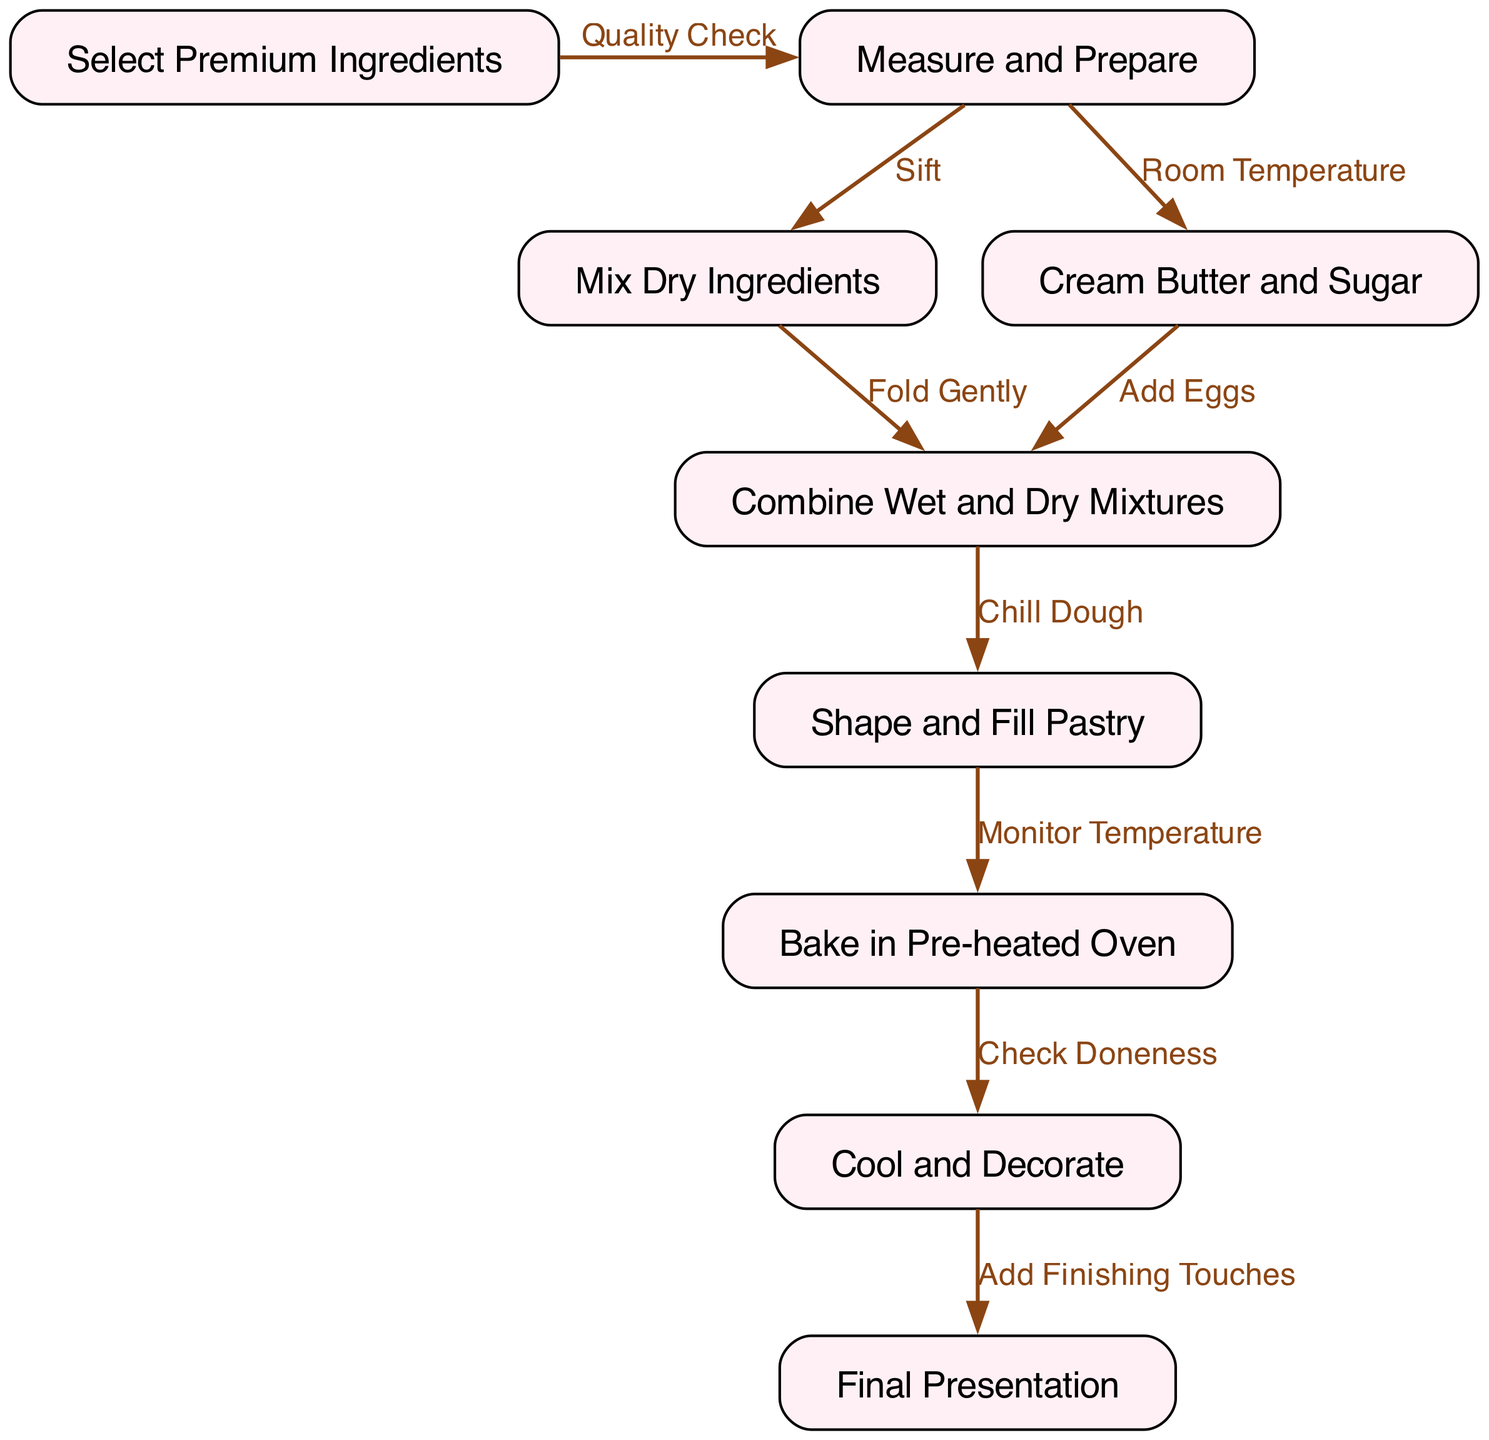What is the first step in the process? The first step is labeled "Select Premium Ingredients," which is the starting node of the diagram.
Answer: Select Premium Ingredients How many nodes are in the diagram? By counting each unique node listed, there are a total of 9 nodes present in the diagram.
Answer: 9 What step comes after mixing the dry ingredients? After mixing dry ingredients labeled as "Mix Dry Ingredients," the next step in the flow is labeled "Combine Wet and Dry Mixtures."
Answer: Combine Wet and Dry Mixtures What process is involved after baking the pastry? After baking the pastry, the diagram indicates the next step is "Cool and Decorate," following the edge "Check Doneness."
Answer: Cool and Decorate What is the relationship between measuring and preparing ingredients and mixing dry ingredients? The relationship is defined by the edge labeled "Sift," which indicates that mixing the dry ingredients occurs after measuring and preparing.
Answer: Sift Which step involves temperature monitoring? The edge labeled "Monitor Temperature" connects to the step "Bake in Pre-heated Oven," indicating that monitoring temperature is part of the baking process.
Answer: Monitor Temperature What is the final step in creating the pastry? The diagram indicates that the last step in the process is labeled "Final Presentation," which concludes the flow.
Answer: Final Presentation How are the ingredients combined before shaping the pastry? The ingredients are combined by chilling the dough after mixing the wet and dry mixtures, as indicated by the edge "Chill Dough."
Answer: Chill Dough What step occurs immediately before final presentation? Before the final presentation, the step "Cool and Decorate" must be completed, as this is directly connected to the last step in the process flow.
Answer: Cool and Decorate 